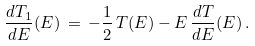<formula> <loc_0><loc_0><loc_500><loc_500>\frac { d T _ { 1 } } { d E } ( E ) \, = \, - \frac { 1 } { 2 } \, T ( E ) - E \, \frac { d T } { d E } ( E ) \, .</formula> 